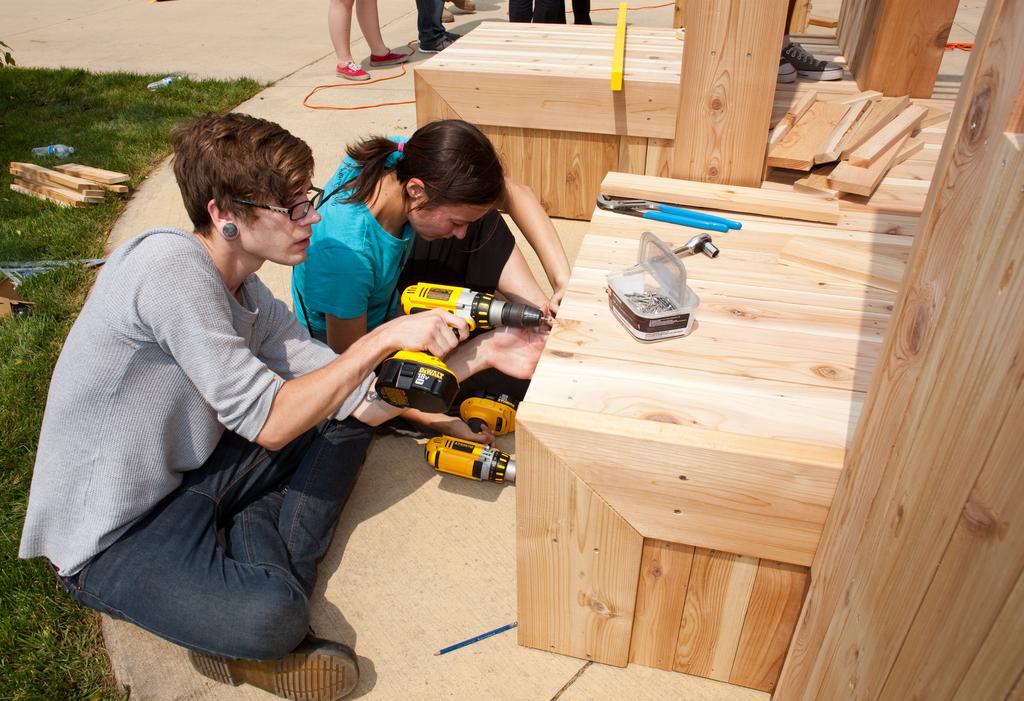In one or two sentences, can you explain what this image depicts? In this image we can see two women sitting on the ground holding the handheld power drills. We can also see a pencil, grass, wooden pieces, bottles, some people standing and some objects placed on the wooden surface. 